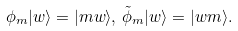Convert formula to latex. <formula><loc_0><loc_0><loc_500><loc_500>\phi _ { m } | w \rangle = | m w \rangle , \, \tilde { \phi } _ { m } | w \rangle = | w m \rangle .</formula> 